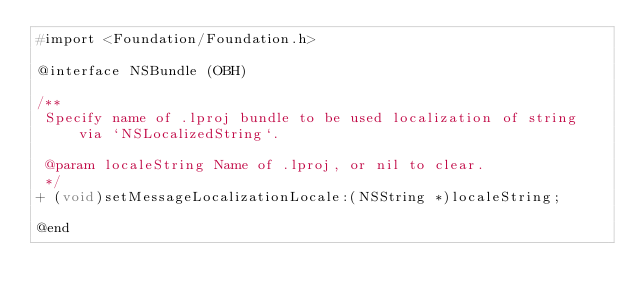Convert code to text. <code><loc_0><loc_0><loc_500><loc_500><_C_>#import <Foundation/Foundation.h>

@interface NSBundle (OBH)

/**
 Specify name of .lproj bundle to be used localization of string via `NSLocalizedString`.
 
 @param localeString Name of .lproj, or nil to clear.
 */
+ (void)setMessageLocalizationLocale:(NSString *)localeString;

@end
</code> 